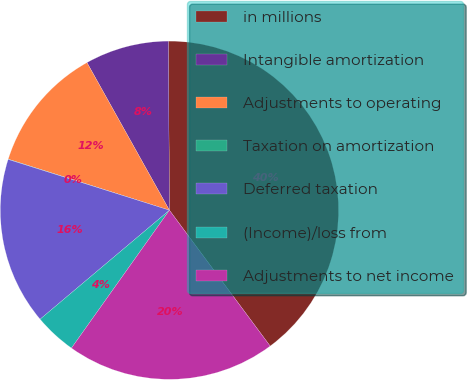<chart> <loc_0><loc_0><loc_500><loc_500><pie_chart><fcel>in millions<fcel>Intangible amortization<fcel>Adjustments to operating<fcel>Taxation on amortization<fcel>Deferred taxation<fcel>(Income)/loss from<fcel>Adjustments to net income<nl><fcel>39.94%<fcel>8.01%<fcel>12.01%<fcel>0.03%<fcel>16.0%<fcel>4.02%<fcel>19.99%<nl></chart> 